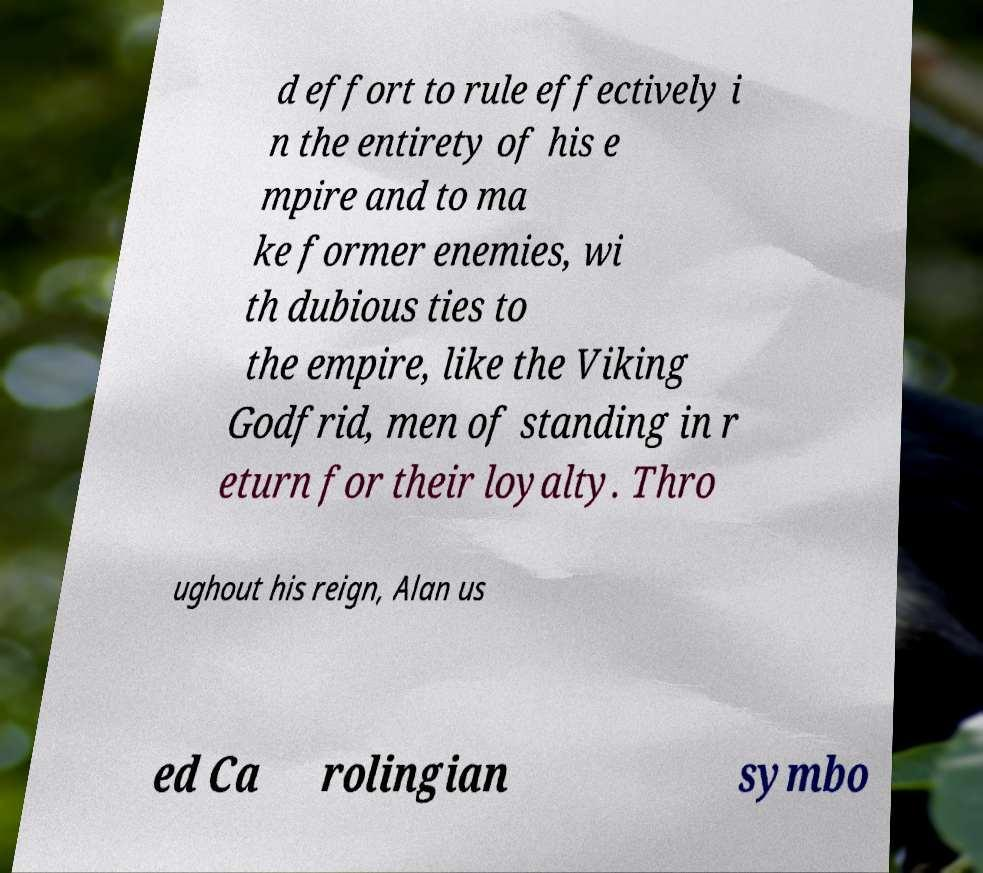For documentation purposes, I need the text within this image transcribed. Could you provide that? d effort to rule effectively i n the entirety of his e mpire and to ma ke former enemies, wi th dubious ties to the empire, like the Viking Godfrid, men of standing in r eturn for their loyalty. Thro ughout his reign, Alan us ed Ca rolingian symbo 